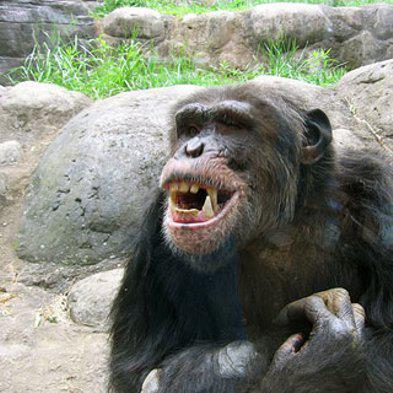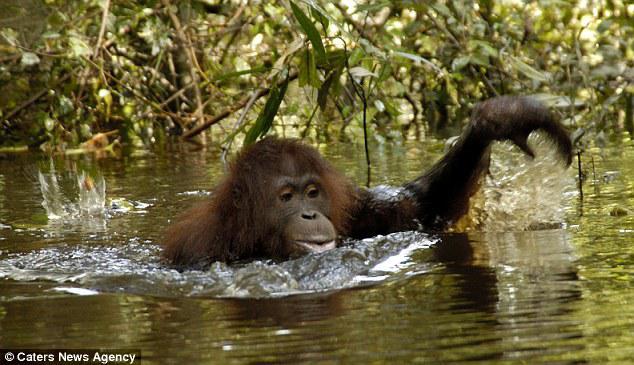The first image is the image on the left, the second image is the image on the right. For the images shown, is this caption "The left image contains one left-facing chimp, and the right image features an ape splashing in water." true? Answer yes or no. Yes. 